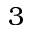<formula> <loc_0><loc_0><loc_500><loc_500>3</formula> 